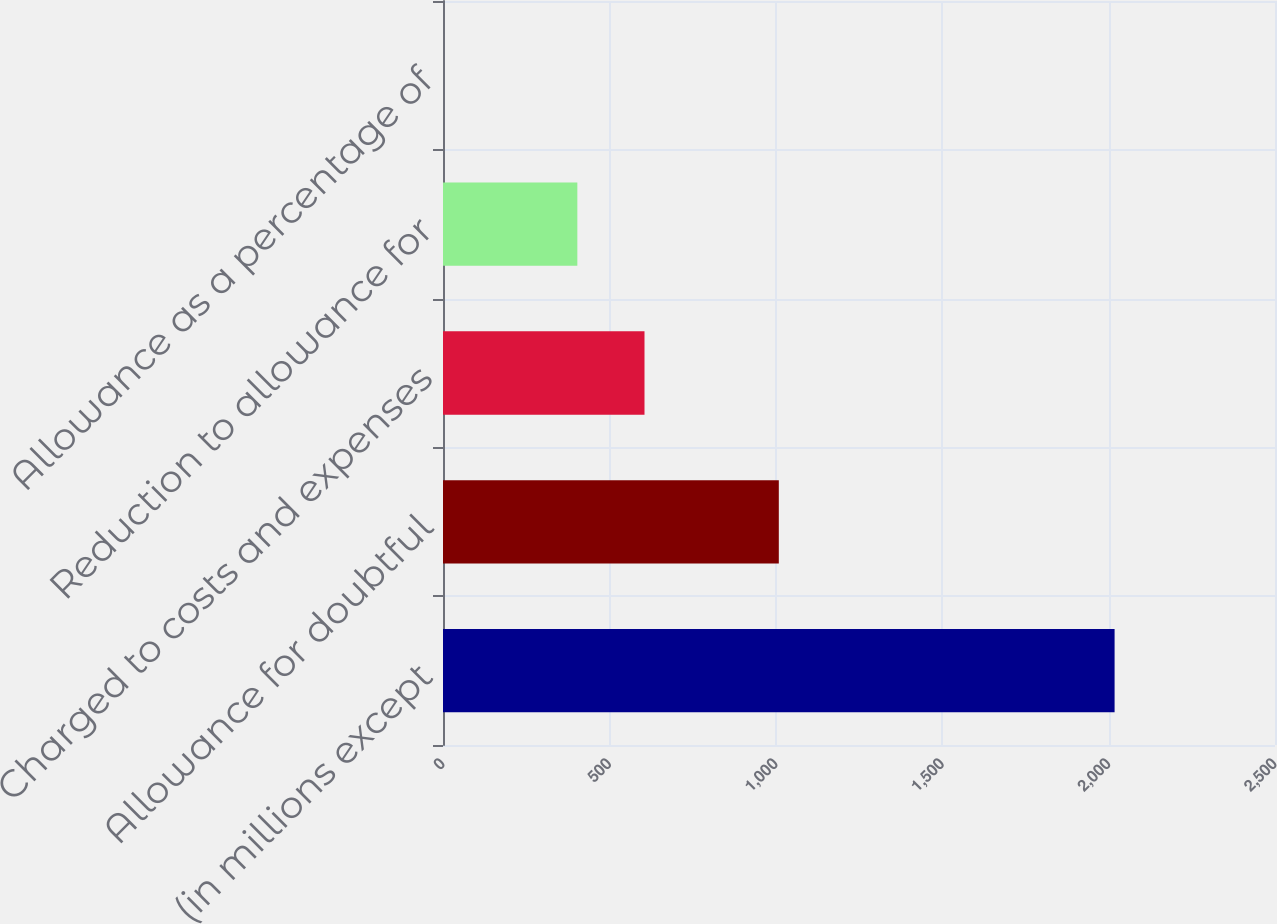Convert chart to OTSL. <chart><loc_0><loc_0><loc_500><loc_500><bar_chart><fcel>(in millions except<fcel>Allowance for doubtful<fcel>Charged to costs and expenses<fcel>Reduction to allowance for<fcel>Allowance as a percentage of<nl><fcel>2018<fcel>1009.05<fcel>605.47<fcel>403.68<fcel>0.1<nl></chart> 